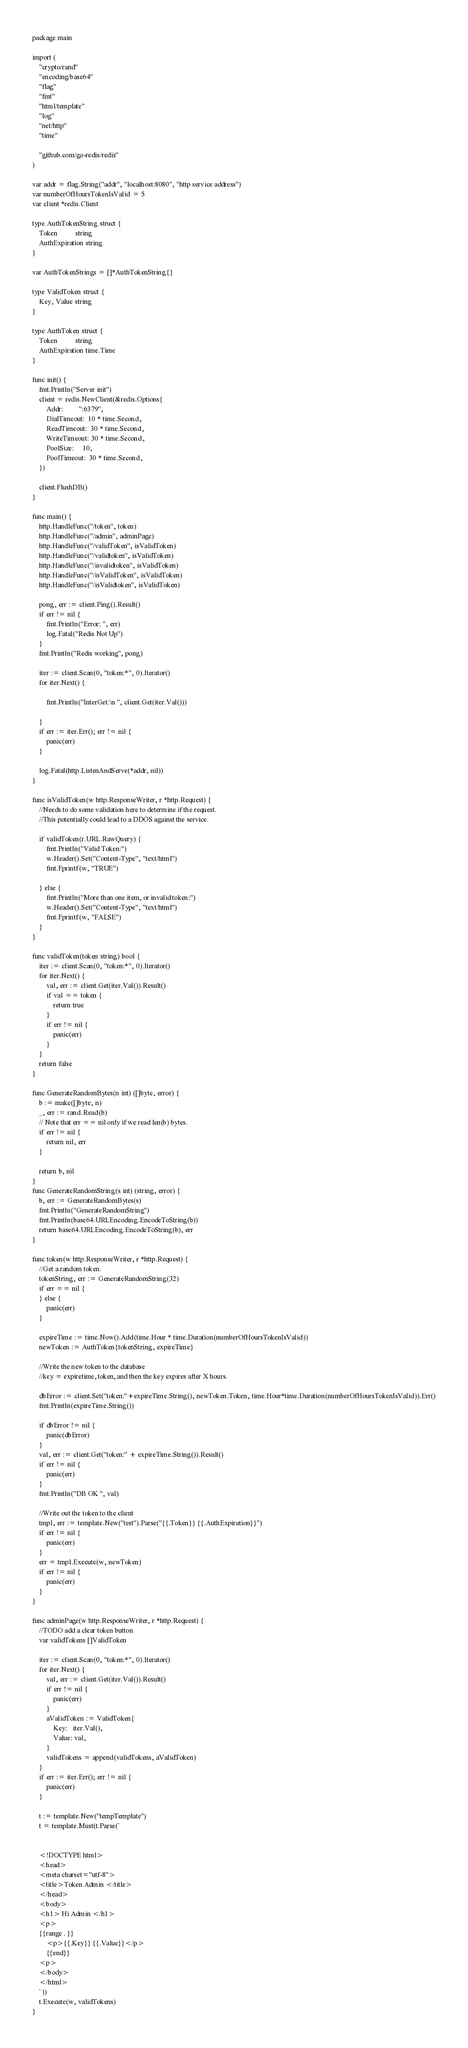<code> <loc_0><loc_0><loc_500><loc_500><_Go_>package main

import (
	"crypto/rand"
	"encoding/base64"
	"flag"
	"fmt"
	"html/template"
	"log"
	"net/http"
	"time"

	"github.com/go-redis/redis"
)

var addr = flag.String("addr", "localhost:8080", "http service address")
var numberOfHoursTokenIsValid = 5
var client *redis.Client

type AuthTokenString struct {
	Token          string
	AuthExpiration string
}

var AuthTokenStrings = []*AuthTokenString{}

type ValidToken struct {
	Key, Value string
}

type AuthToken struct {
	Token          string
	AuthExpiration time.Time
}

func init() {
	fmt.Println("Server init")
	client = redis.NewClient(&redis.Options{
		Addr:         ":6379",
		DialTimeout:  10 * time.Second,
		ReadTimeout:  30 * time.Second,
		WriteTimeout: 30 * time.Second,
		PoolSize:     10,
		PoolTimeout:  30 * time.Second,
	})

	client.FlushDB()
}

func main() {
	http.HandleFunc("/token", token)
	http.HandleFunc("/admin", adminPage)
	http.HandleFunc("/validToken", isValidToken)
	http.HandleFunc("/validtoken", isValidToken)
	http.HandleFunc("/isvalidtoken", isValidToken)
	http.HandleFunc("/isValidToken", isValidToken)
	http.HandleFunc("/isValidtoken", isValidToken)

	pong, err := client.Ping().Result()
	if err != nil {
		fmt.Println("Error: ", err)
		log.Fatal("Redis Not Up")
	}
	fmt.Println("Redis working", pong)

	iter := client.Scan(0, "token:*", 0).Iterator()
	for iter.Next() {

		fmt.Println("InterGet:\n ", client.Get(iter.Val()))

	}
	if err := iter.Err(); err != nil {
		panic(err)
	}

	log.Fatal(http.ListenAndServe(*addr, nil))
}

func isValidToken(w http.ResponseWriter, r *http.Request) {
	//Needs to do some validation here to determine if the request.
	//This potentially could lead to a DDOS against the service.

	if validToken(r.URL.RawQuery) {
		fmt.Println("Valid Token:")
		w.Header().Set("Content-Type", "text/html")
		fmt.Fprintf(w, "TRUE")

	} else {
		fmt.Println("More than one item, or invalid token:")
		w.Header().Set("Content-Type", "text/html")
		fmt.Fprintf(w, "FALSE")
	}
}

func validToken(token string) bool {
	iter := client.Scan(0, "token:*", 0).Iterator()
	for iter.Next() {
		val, err := client.Get(iter.Val()).Result()
		if val == token {
			return true
		}
		if err != nil {
			panic(err)
		}
	}
	return false
}

func GenerateRandomBytes(n int) ([]byte, error) {
	b := make([]byte, n)
	_, err := rand.Read(b)
	// Note that err == nil only if we read len(b) bytes.
	if err != nil {
		return nil, err
	}

	return b, nil
}
func GenerateRandomString(s int) (string, error) {
	b, err := GenerateRandomBytes(s)
	fmt.Println("GenerateRandomString")
	fmt.Println(base64.URLEncoding.EncodeToString(b))
	return base64.URLEncoding.EncodeToString(b), err
}

func token(w http.ResponseWriter, r *http.Request) {
	//Get a random token.
	tokenString, err := GenerateRandomString(32)
	if err == nil {
	} else {
		panic(err)
	}

	expireTime := time.Now().Add(time.Hour * time.Duration(numberOfHoursTokenIsValid))
	newToken := AuthToken{tokenString, expireTime}

	//Write the new token to the database
	//key = expiretime, token, and then the key expires after X hours.

	dbError := client.Set("token:"+expireTime.String(), newToken.Token, time.Hour*time.Duration(numberOfHoursTokenIsValid)).Err()
	fmt.Println(expireTime.String())

	if dbError != nil {
		panic(dbError)
	}
	val, err := client.Get("token:" + expireTime.String()).Result()
	if err != nil {
		panic(err)
	}
	fmt.Println("DB OK ", val)

	//Write out the token to the client
	tmpl, err := template.New("test").Parse("{{.Token}} {{.AuthExpiration}}")
	if err != nil {
		panic(err)
	}
	err = tmpl.Execute(w, newToken)
	if err != nil {
		panic(err)
	}
}

func adminPage(w http.ResponseWriter, r *http.Request) {
	//TODO add a clear token button
	var validTokens []ValidToken

	iter := client.Scan(0, "token:*", 0).Iterator()
	for iter.Next() {
		val, err := client.Get(iter.Val()).Result()
		if err != nil {
			panic(err)
		}
		aValidToken := ValidToken{
			Key:   iter.Val(),
			Value: val,
		}
		validTokens = append(validTokens, aValidToken)
	}
	if err := iter.Err(); err != nil {
		panic(err)
	}

	t := template.New("tempTemplate")
	t = template.Must(t.Parse(`
	

	<!DOCTYPE html> 
	<head> 
	<meta charset="utf-8"> 
	<title>Token Admin </title> 
	</head> 
	<body> 
	<h1> Hi Admin </h1>
	<p> 
	{{range . }}
		<p>{{.Key}} {{.Value}}</p> 
		{{end}}
	<p> 
	</body> 
	</html> 
	`))
	t.Execute(w, validTokens)
}
</code> 